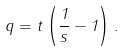<formula> <loc_0><loc_0><loc_500><loc_500>q = t \left ( \frac { 1 } { s } - 1 \right ) .</formula> 